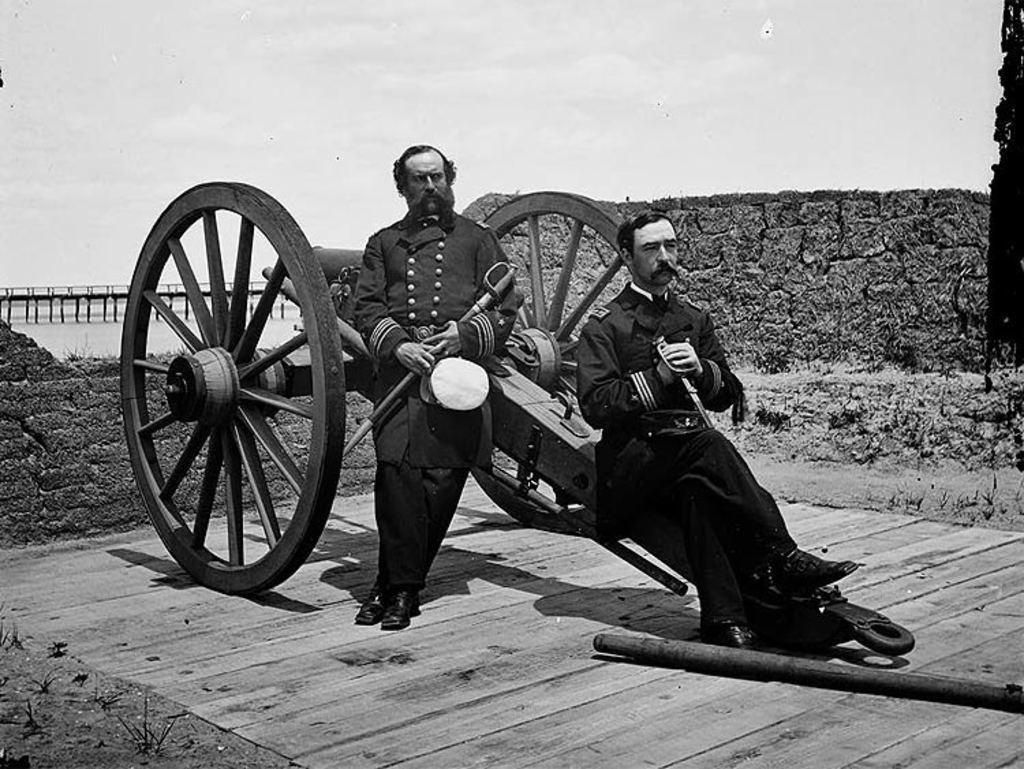How would you summarize this image in a sentence or two? In this image there is a cart vehicle, in front of the vehicle there are two persons visible, at the top there is the sky, there is a a bridge visible on the left side, behind the vehicle there is the wall, in the foreground there may be a metal rod, persons holding may be swords. 